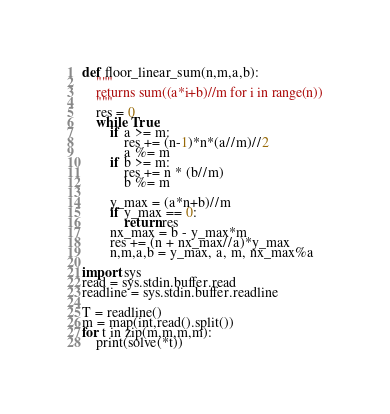Convert code to text. <code><loc_0><loc_0><loc_500><loc_500><_Python_>def floor_linear_sum(n,m,a,b):
    """
    returns sum((a*i+b)//m for i in range(n))
    """
    res = 0
    while True:
        if a >= m:
            res += (n-1)*n*(a//m)//2
            a %= m
        if b >= m:
            res += n * (b//m)
            b %= m

        y_max = (a*n+b)//m
        if y_max == 0:
            return res
        nx_max = b - y_max*m
        res += (n + nx_max//a)*y_max
        n,m,a,b = y_max, a, m, nx_max%a

import sys
read = sys.stdin.buffer.read
readline = sys.stdin.buffer.readline

T = readline()
m = map(int,read().split())
for t in zip(m,m,m,m):
    print(solve(*t))</code> 